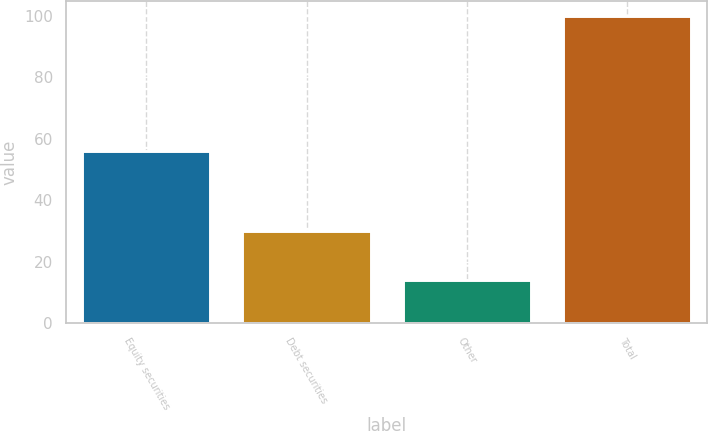<chart> <loc_0><loc_0><loc_500><loc_500><bar_chart><fcel>Equity securities<fcel>Debt securities<fcel>Other<fcel>Total<nl><fcel>56<fcel>30<fcel>14<fcel>100<nl></chart> 